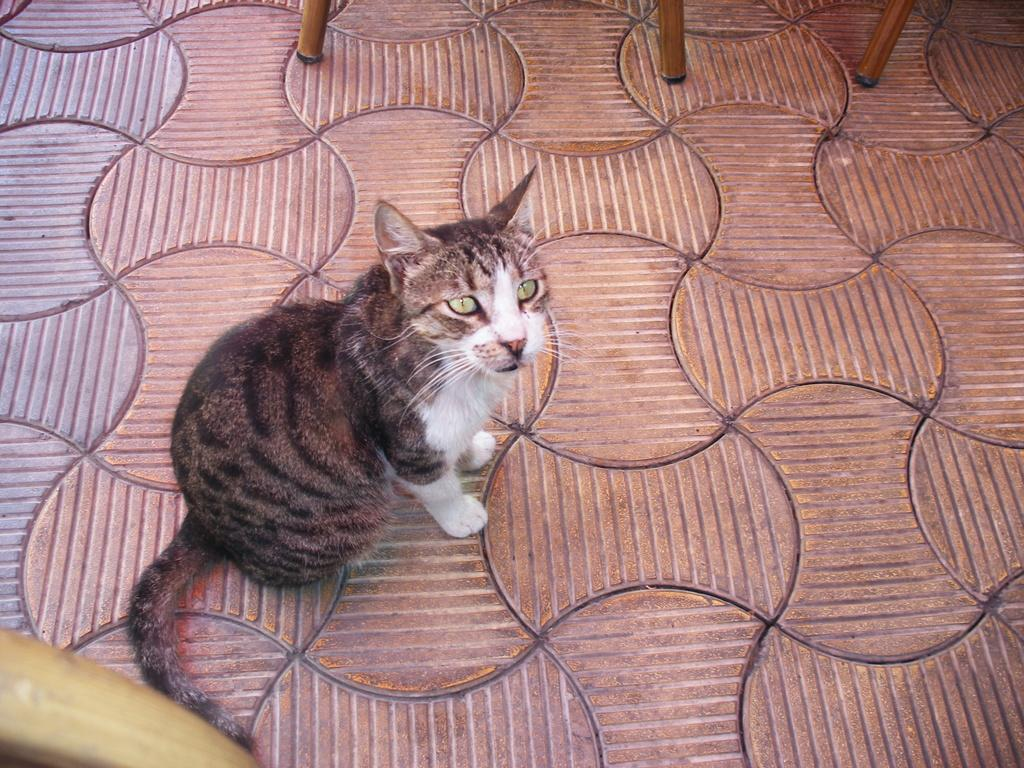What type of animal is in the image? There is a cat in the image. Where is the cat located in the image? The cat is sitting on the tile floor. What type of flooring is visible in the image? The flooring is tile. What other objects can be seen in the image? There are wooden objects at the bottom and top of the image. What type of government is depicted in the image? There is no depiction of a government in the image; it features a cat sitting on a tile floor with wooden objects in the background. 